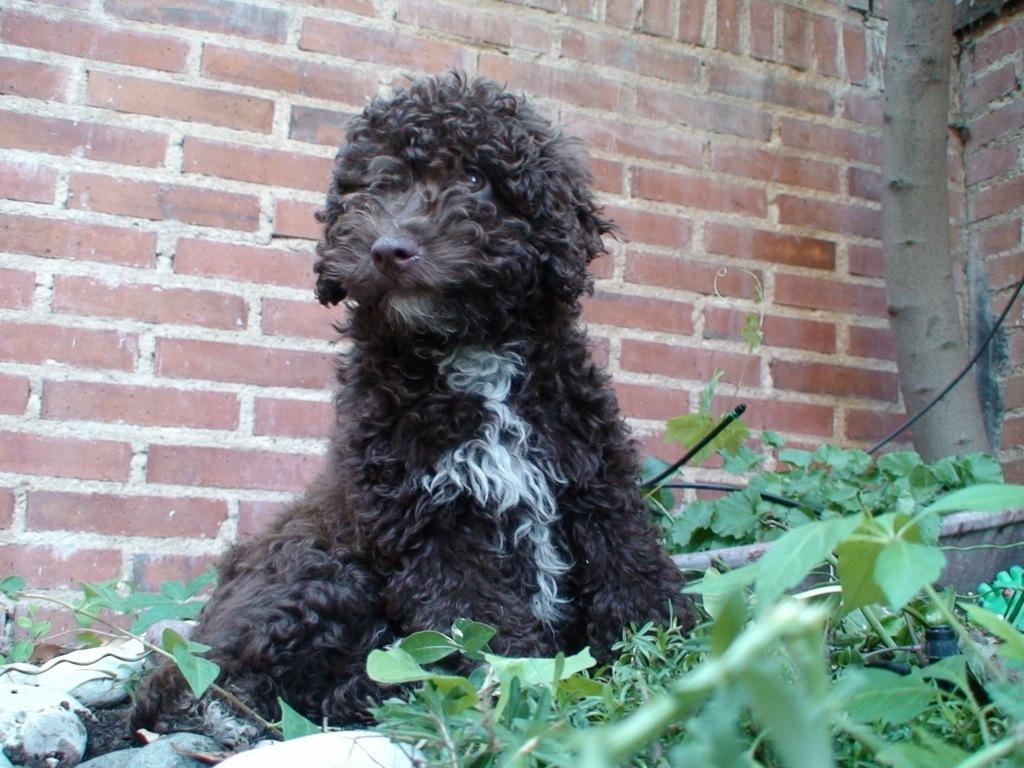What type of animal is present in the image? There is a dog in the image. What other living organisms can be seen in the image? There are plants in the image. What can be seen in the background of the image? There is a wall in the background of the image. What type of nail polish is the dog wearing in the image? There is no nail polish present in the image, as dogs do not wear nail polish. 